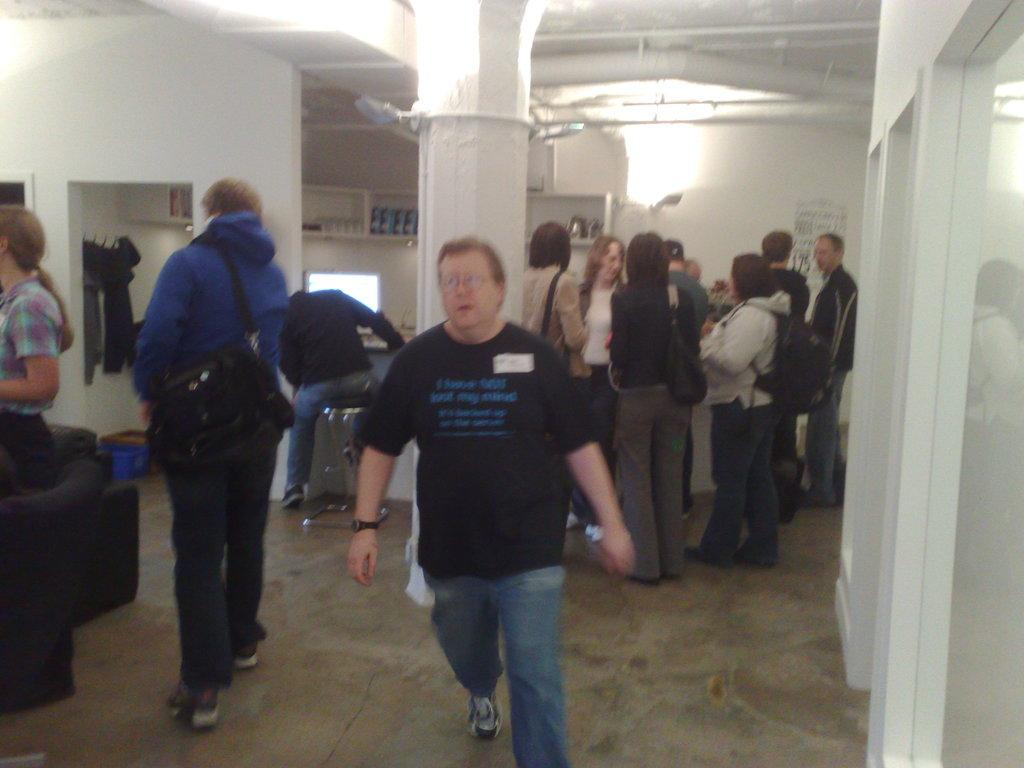What are the two people in the image doing? The two people in the image are walking. Can you describe what one of the people is carrying? One of the people is carrying a bag. What are the other people in the image doing? There are people standing in the image. What objects can be seen in the image besides the people? There is a chair and a pillar in the image. What can be seen in the background of the image? There is a wall and light visible in the background of the image. What type of jeans is the girl wearing in the image? There is no girl present in the image, and therefore no jeans to describe. What type of popcorn can be seen in the image? There is no popcorn present in the image. 